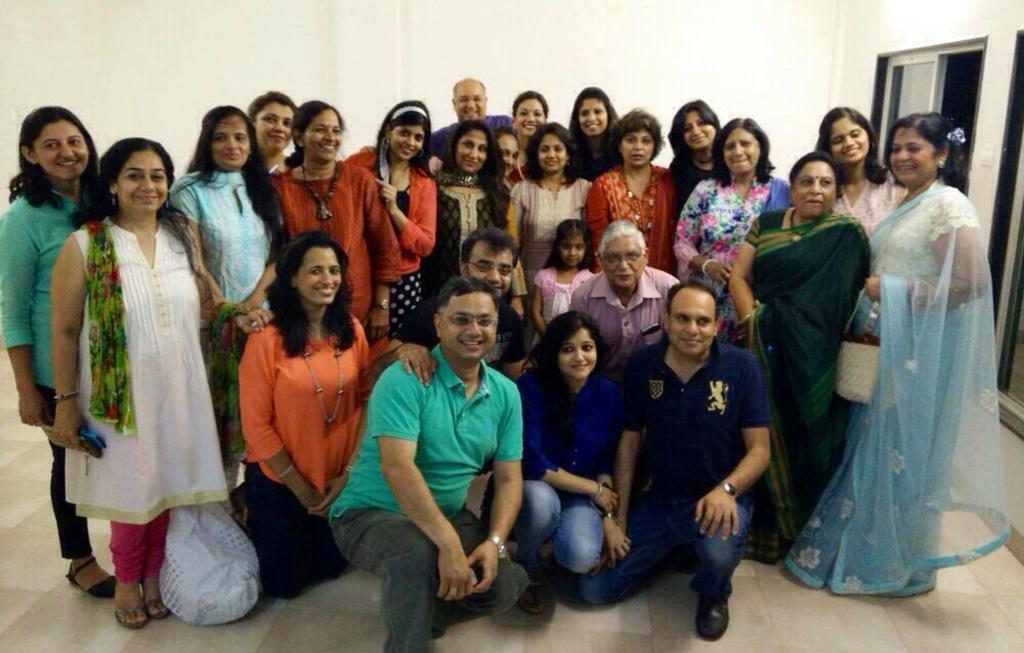What can be seen in the image? There is a group of ladies in the image, and they are standing together. Are there any other people in the image? Yes, there are men standing in front of the group of ladies. How are the people in the image feeling? The people in the image are smiling. What is behind the group of people? There is a wall behind the group of people. What architectural feature can be seen on the right side of the image? There is a window on the right side of the image. What type of polish is being applied to the bridge in the image? There is no bridge or polish present in the image. How are the people in the image pushing each other? The people in the image are not pushing each other; they are standing together and smiling. 